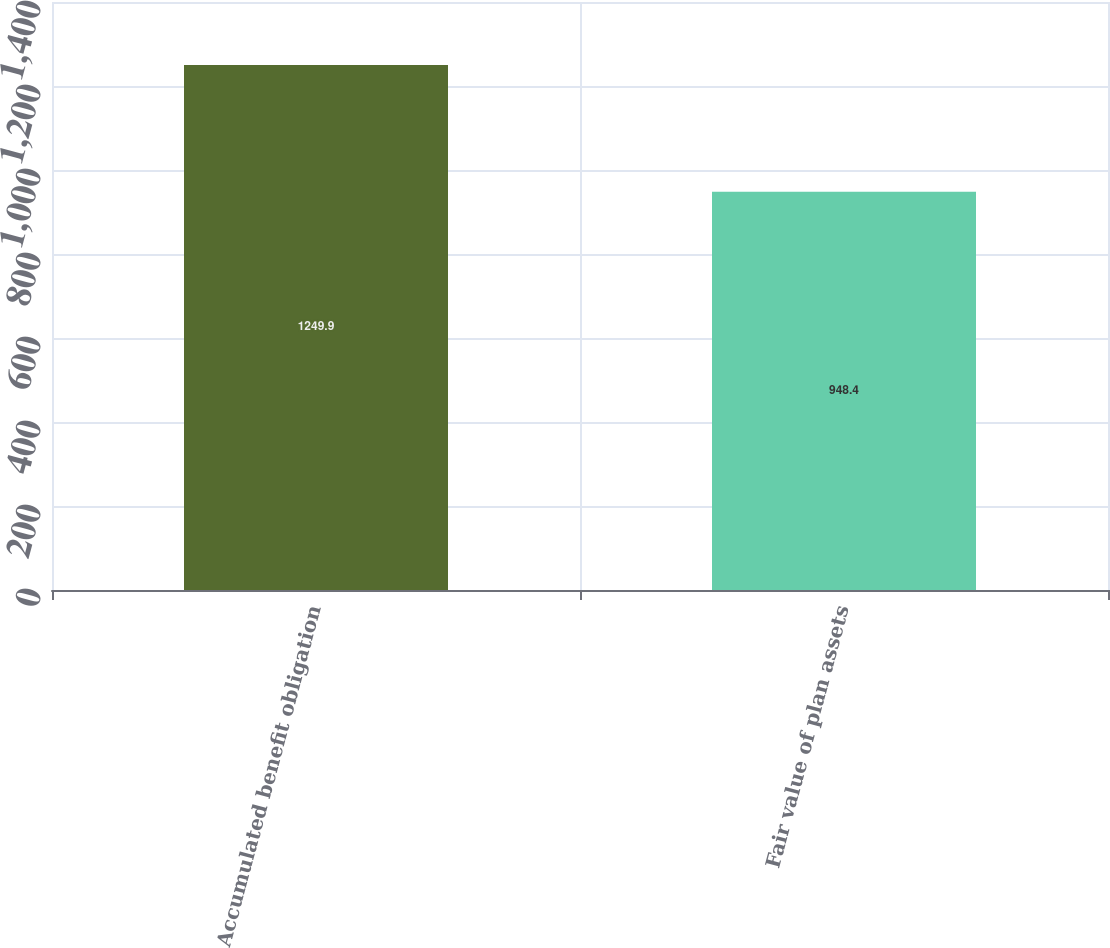Convert chart. <chart><loc_0><loc_0><loc_500><loc_500><bar_chart><fcel>Accumulated benefit obligation<fcel>Fair value of plan assets<nl><fcel>1249.9<fcel>948.4<nl></chart> 